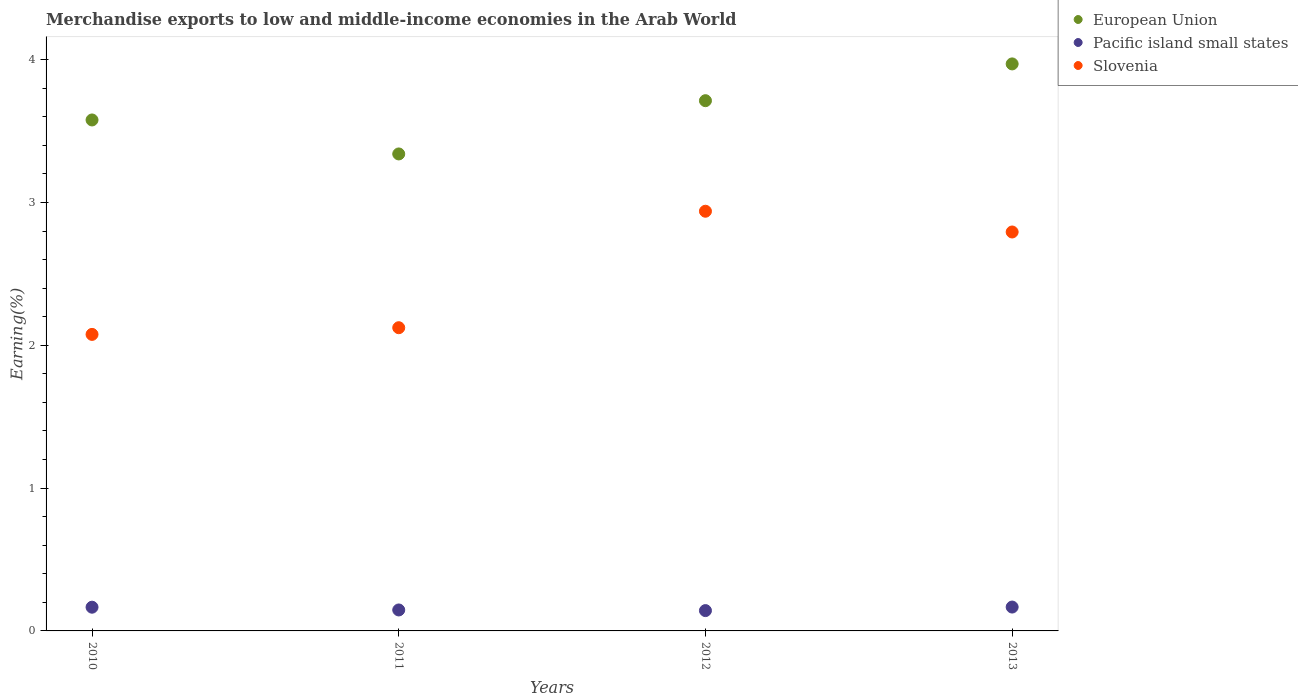How many different coloured dotlines are there?
Provide a succinct answer. 3. What is the percentage of amount earned from merchandise exports in Slovenia in 2011?
Your response must be concise. 2.12. Across all years, what is the maximum percentage of amount earned from merchandise exports in Slovenia?
Offer a very short reply. 2.94. Across all years, what is the minimum percentage of amount earned from merchandise exports in European Union?
Your answer should be compact. 3.34. In which year was the percentage of amount earned from merchandise exports in Pacific island small states maximum?
Give a very brief answer. 2013. In which year was the percentage of amount earned from merchandise exports in Pacific island small states minimum?
Provide a short and direct response. 2012. What is the total percentage of amount earned from merchandise exports in European Union in the graph?
Offer a very short reply. 14.6. What is the difference between the percentage of amount earned from merchandise exports in Slovenia in 2012 and that in 2013?
Provide a short and direct response. 0.15. What is the difference between the percentage of amount earned from merchandise exports in Pacific island small states in 2011 and the percentage of amount earned from merchandise exports in Slovenia in 2013?
Make the answer very short. -2.65. What is the average percentage of amount earned from merchandise exports in Pacific island small states per year?
Provide a short and direct response. 0.16. In the year 2010, what is the difference between the percentage of amount earned from merchandise exports in European Union and percentage of amount earned from merchandise exports in Slovenia?
Your answer should be very brief. 1.5. What is the ratio of the percentage of amount earned from merchandise exports in European Union in 2010 to that in 2013?
Offer a very short reply. 0.9. Is the percentage of amount earned from merchandise exports in European Union in 2011 less than that in 2012?
Make the answer very short. Yes. Is the difference between the percentage of amount earned from merchandise exports in European Union in 2011 and 2013 greater than the difference between the percentage of amount earned from merchandise exports in Slovenia in 2011 and 2013?
Provide a succinct answer. Yes. What is the difference between the highest and the second highest percentage of amount earned from merchandise exports in Slovenia?
Your response must be concise. 0.15. What is the difference between the highest and the lowest percentage of amount earned from merchandise exports in Slovenia?
Offer a terse response. 0.86. Is the percentage of amount earned from merchandise exports in Slovenia strictly greater than the percentage of amount earned from merchandise exports in Pacific island small states over the years?
Your response must be concise. Yes. How many dotlines are there?
Make the answer very short. 3. Does the graph contain any zero values?
Offer a terse response. No. Does the graph contain grids?
Keep it short and to the point. No. How many legend labels are there?
Offer a very short reply. 3. What is the title of the graph?
Keep it short and to the point. Merchandise exports to low and middle-income economies in the Arab World. What is the label or title of the Y-axis?
Keep it short and to the point. Earning(%). What is the Earning(%) of European Union in 2010?
Your answer should be compact. 3.58. What is the Earning(%) in Pacific island small states in 2010?
Your answer should be very brief. 0.17. What is the Earning(%) of Slovenia in 2010?
Provide a short and direct response. 2.08. What is the Earning(%) of European Union in 2011?
Offer a very short reply. 3.34. What is the Earning(%) in Pacific island small states in 2011?
Provide a short and direct response. 0.15. What is the Earning(%) of Slovenia in 2011?
Ensure brevity in your answer.  2.12. What is the Earning(%) in European Union in 2012?
Make the answer very short. 3.71. What is the Earning(%) in Pacific island small states in 2012?
Your answer should be very brief. 0.14. What is the Earning(%) in Slovenia in 2012?
Your response must be concise. 2.94. What is the Earning(%) of European Union in 2013?
Your answer should be compact. 3.97. What is the Earning(%) of Pacific island small states in 2013?
Offer a very short reply. 0.17. What is the Earning(%) of Slovenia in 2013?
Your response must be concise. 2.79. Across all years, what is the maximum Earning(%) in European Union?
Your response must be concise. 3.97. Across all years, what is the maximum Earning(%) of Pacific island small states?
Give a very brief answer. 0.17. Across all years, what is the maximum Earning(%) in Slovenia?
Provide a short and direct response. 2.94. Across all years, what is the minimum Earning(%) in European Union?
Ensure brevity in your answer.  3.34. Across all years, what is the minimum Earning(%) in Pacific island small states?
Keep it short and to the point. 0.14. Across all years, what is the minimum Earning(%) of Slovenia?
Your answer should be compact. 2.08. What is the total Earning(%) in European Union in the graph?
Provide a short and direct response. 14.6. What is the total Earning(%) in Pacific island small states in the graph?
Your answer should be very brief. 0.62. What is the total Earning(%) of Slovenia in the graph?
Provide a short and direct response. 9.93. What is the difference between the Earning(%) in European Union in 2010 and that in 2011?
Provide a succinct answer. 0.24. What is the difference between the Earning(%) in Pacific island small states in 2010 and that in 2011?
Give a very brief answer. 0.02. What is the difference between the Earning(%) in Slovenia in 2010 and that in 2011?
Give a very brief answer. -0.05. What is the difference between the Earning(%) of European Union in 2010 and that in 2012?
Make the answer very short. -0.14. What is the difference between the Earning(%) of Pacific island small states in 2010 and that in 2012?
Offer a terse response. 0.02. What is the difference between the Earning(%) in Slovenia in 2010 and that in 2012?
Offer a very short reply. -0.86. What is the difference between the Earning(%) of European Union in 2010 and that in 2013?
Make the answer very short. -0.39. What is the difference between the Earning(%) of Pacific island small states in 2010 and that in 2013?
Ensure brevity in your answer.  -0. What is the difference between the Earning(%) of Slovenia in 2010 and that in 2013?
Your response must be concise. -0.72. What is the difference between the Earning(%) in European Union in 2011 and that in 2012?
Your response must be concise. -0.37. What is the difference between the Earning(%) of Pacific island small states in 2011 and that in 2012?
Provide a short and direct response. 0. What is the difference between the Earning(%) of Slovenia in 2011 and that in 2012?
Provide a succinct answer. -0.82. What is the difference between the Earning(%) of European Union in 2011 and that in 2013?
Your response must be concise. -0.63. What is the difference between the Earning(%) of Pacific island small states in 2011 and that in 2013?
Make the answer very short. -0.02. What is the difference between the Earning(%) of Slovenia in 2011 and that in 2013?
Provide a short and direct response. -0.67. What is the difference between the Earning(%) in European Union in 2012 and that in 2013?
Offer a terse response. -0.26. What is the difference between the Earning(%) in Pacific island small states in 2012 and that in 2013?
Provide a succinct answer. -0.02. What is the difference between the Earning(%) of Slovenia in 2012 and that in 2013?
Keep it short and to the point. 0.15. What is the difference between the Earning(%) in European Union in 2010 and the Earning(%) in Pacific island small states in 2011?
Offer a terse response. 3.43. What is the difference between the Earning(%) of European Union in 2010 and the Earning(%) of Slovenia in 2011?
Your response must be concise. 1.45. What is the difference between the Earning(%) in Pacific island small states in 2010 and the Earning(%) in Slovenia in 2011?
Keep it short and to the point. -1.96. What is the difference between the Earning(%) of European Union in 2010 and the Earning(%) of Pacific island small states in 2012?
Provide a short and direct response. 3.44. What is the difference between the Earning(%) in European Union in 2010 and the Earning(%) in Slovenia in 2012?
Make the answer very short. 0.64. What is the difference between the Earning(%) of Pacific island small states in 2010 and the Earning(%) of Slovenia in 2012?
Your response must be concise. -2.77. What is the difference between the Earning(%) in European Union in 2010 and the Earning(%) in Pacific island small states in 2013?
Give a very brief answer. 3.41. What is the difference between the Earning(%) in European Union in 2010 and the Earning(%) in Slovenia in 2013?
Keep it short and to the point. 0.78. What is the difference between the Earning(%) in Pacific island small states in 2010 and the Earning(%) in Slovenia in 2013?
Give a very brief answer. -2.63. What is the difference between the Earning(%) of European Union in 2011 and the Earning(%) of Pacific island small states in 2012?
Give a very brief answer. 3.2. What is the difference between the Earning(%) in European Union in 2011 and the Earning(%) in Slovenia in 2012?
Ensure brevity in your answer.  0.4. What is the difference between the Earning(%) in Pacific island small states in 2011 and the Earning(%) in Slovenia in 2012?
Provide a succinct answer. -2.79. What is the difference between the Earning(%) of European Union in 2011 and the Earning(%) of Pacific island small states in 2013?
Offer a terse response. 3.17. What is the difference between the Earning(%) of European Union in 2011 and the Earning(%) of Slovenia in 2013?
Provide a short and direct response. 0.55. What is the difference between the Earning(%) in Pacific island small states in 2011 and the Earning(%) in Slovenia in 2013?
Make the answer very short. -2.65. What is the difference between the Earning(%) of European Union in 2012 and the Earning(%) of Pacific island small states in 2013?
Your answer should be very brief. 3.55. What is the difference between the Earning(%) of European Union in 2012 and the Earning(%) of Slovenia in 2013?
Offer a terse response. 0.92. What is the difference between the Earning(%) of Pacific island small states in 2012 and the Earning(%) of Slovenia in 2013?
Your answer should be compact. -2.65. What is the average Earning(%) in European Union per year?
Offer a terse response. 3.65. What is the average Earning(%) in Pacific island small states per year?
Make the answer very short. 0.16. What is the average Earning(%) of Slovenia per year?
Offer a terse response. 2.48. In the year 2010, what is the difference between the Earning(%) in European Union and Earning(%) in Pacific island small states?
Your response must be concise. 3.41. In the year 2010, what is the difference between the Earning(%) in European Union and Earning(%) in Slovenia?
Ensure brevity in your answer.  1.5. In the year 2010, what is the difference between the Earning(%) in Pacific island small states and Earning(%) in Slovenia?
Your response must be concise. -1.91. In the year 2011, what is the difference between the Earning(%) of European Union and Earning(%) of Pacific island small states?
Keep it short and to the point. 3.19. In the year 2011, what is the difference between the Earning(%) of European Union and Earning(%) of Slovenia?
Offer a very short reply. 1.22. In the year 2011, what is the difference between the Earning(%) of Pacific island small states and Earning(%) of Slovenia?
Make the answer very short. -1.98. In the year 2012, what is the difference between the Earning(%) in European Union and Earning(%) in Pacific island small states?
Offer a terse response. 3.57. In the year 2012, what is the difference between the Earning(%) of European Union and Earning(%) of Slovenia?
Your response must be concise. 0.77. In the year 2012, what is the difference between the Earning(%) in Pacific island small states and Earning(%) in Slovenia?
Keep it short and to the point. -2.8. In the year 2013, what is the difference between the Earning(%) in European Union and Earning(%) in Pacific island small states?
Provide a short and direct response. 3.8. In the year 2013, what is the difference between the Earning(%) in European Union and Earning(%) in Slovenia?
Your response must be concise. 1.18. In the year 2013, what is the difference between the Earning(%) of Pacific island small states and Earning(%) of Slovenia?
Your answer should be compact. -2.63. What is the ratio of the Earning(%) of European Union in 2010 to that in 2011?
Your answer should be very brief. 1.07. What is the ratio of the Earning(%) in Pacific island small states in 2010 to that in 2011?
Ensure brevity in your answer.  1.13. What is the ratio of the Earning(%) in Slovenia in 2010 to that in 2011?
Make the answer very short. 0.98. What is the ratio of the Earning(%) of European Union in 2010 to that in 2012?
Make the answer very short. 0.96. What is the ratio of the Earning(%) in Pacific island small states in 2010 to that in 2012?
Ensure brevity in your answer.  1.17. What is the ratio of the Earning(%) of Slovenia in 2010 to that in 2012?
Ensure brevity in your answer.  0.71. What is the ratio of the Earning(%) of European Union in 2010 to that in 2013?
Offer a very short reply. 0.9. What is the ratio of the Earning(%) in Slovenia in 2010 to that in 2013?
Your response must be concise. 0.74. What is the ratio of the Earning(%) in European Union in 2011 to that in 2012?
Offer a terse response. 0.9. What is the ratio of the Earning(%) in Pacific island small states in 2011 to that in 2012?
Your answer should be compact. 1.03. What is the ratio of the Earning(%) in Slovenia in 2011 to that in 2012?
Provide a short and direct response. 0.72. What is the ratio of the Earning(%) in European Union in 2011 to that in 2013?
Make the answer very short. 0.84. What is the ratio of the Earning(%) in Pacific island small states in 2011 to that in 2013?
Give a very brief answer. 0.88. What is the ratio of the Earning(%) in Slovenia in 2011 to that in 2013?
Give a very brief answer. 0.76. What is the ratio of the Earning(%) in European Union in 2012 to that in 2013?
Your answer should be compact. 0.94. What is the ratio of the Earning(%) of Pacific island small states in 2012 to that in 2013?
Offer a very short reply. 0.85. What is the ratio of the Earning(%) of Slovenia in 2012 to that in 2013?
Ensure brevity in your answer.  1.05. What is the difference between the highest and the second highest Earning(%) of European Union?
Ensure brevity in your answer.  0.26. What is the difference between the highest and the second highest Earning(%) in Pacific island small states?
Offer a very short reply. 0. What is the difference between the highest and the second highest Earning(%) of Slovenia?
Offer a terse response. 0.15. What is the difference between the highest and the lowest Earning(%) of European Union?
Ensure brevity in your answer.  0.63. What is the difference between the highest and the lowest Earning(%) of Pacific island small states?
Keep it short and to the point. 0.02. What is the difference between the highest and the lowest Earning(%) in Slovenia?
Offer a terse response. 0.86. 